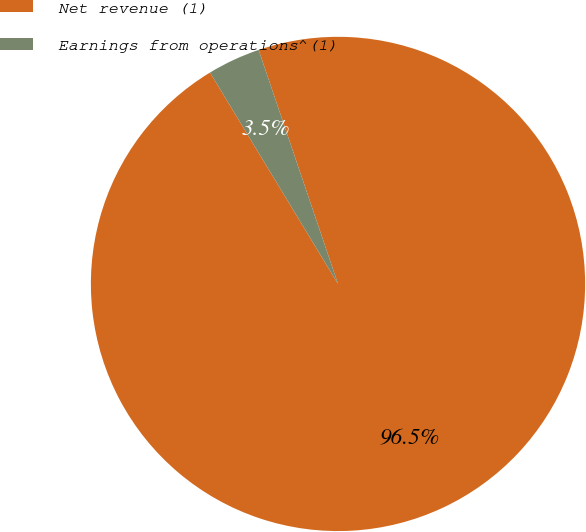Convert chart. <chart><loc_0><loc_0><loc_500><loc_500><pie_chart><fcel>Net revenue (1)<fcel>Earnings from operations^(1)<nl><fcel>96.54%<fcel>3.46%<nl></chart> 